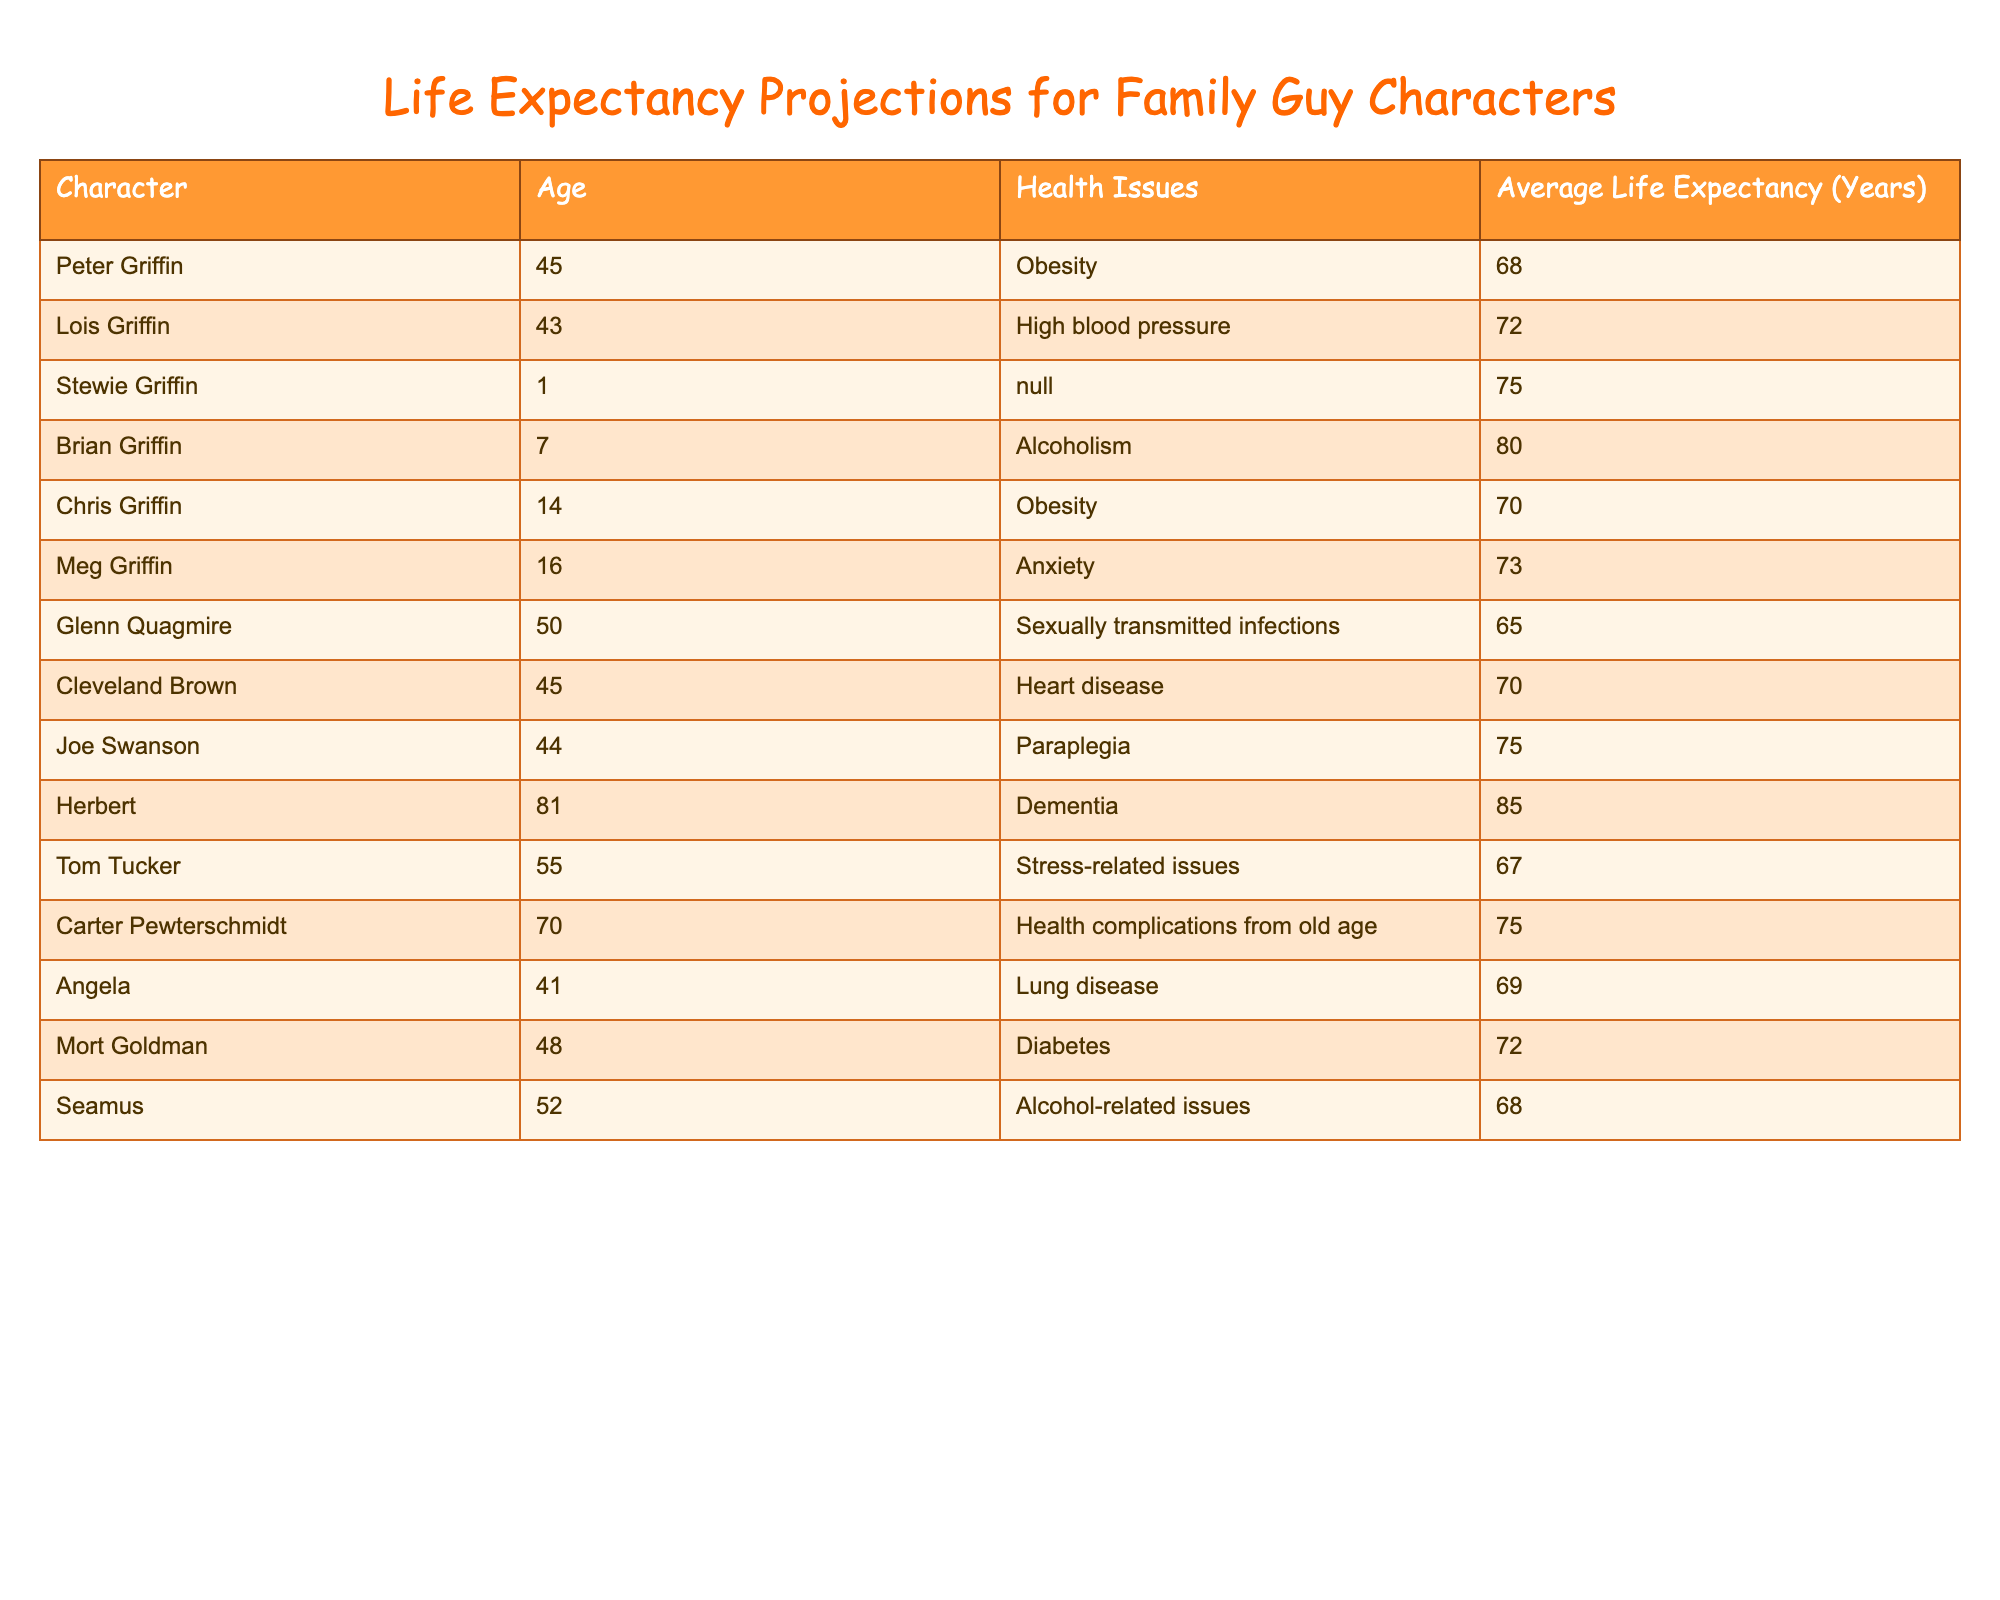What is the average life expectancy for the characters from Family Guy? To find the average life expectancy, we first sum all the life expectancies: (68 + 72 + 75 + 80 + 70 + 73 + 65 + 70 + 75 + 85 + 67 + 75 + 69 + 72 + 68) = 1075. Then we divide that by the total number of characters, which is 15. Therefore, the average life expectancy is 1075 / 15 = 71.67 years.
Answer: 71.67 Which character has the highest life expectancy? By reviewing the life expectancies of all characters, we see that Herbert has the highest score of 85 years.
Answer: Herbert Is it true that Cleveland Brown has a higher life expectancy than Joe Swanson? Cleveland Brown has a life expectancy of 70 years, while Joe Swanson has a life expectancy of 75 years. Since 70 is not greater than 75, the statement is false.
Answer: No What is the difference in life expectancy between Peter Griffin and Glenn Quagmire? Peter Griffin has a life expectancy of 68 years, while Glenn Quagmire has a life expectancy of 65 years. The difference is 68 - 65 = 3 years.
Answer: 3 years How many characters have a life expectancy above 75 years? The characters with life expectancy above 75 years are Stewie Griffin (75), Brian Griffin (80), Joe Swanson (75), Herbert (85), and Carter Pewterschmidt (75). Therefore, there are 5 characters in total.
Answer: 5 characters Is Angela's health issue more serious than that of Chris Griffin? Angela has lung disease, considered serious, while Chris has obesity, also serious but generally seen as less immediately life-threatening than lung disease. However, health issues are subjective. So, this can be seen as true or false based on perspective.
Answer: Yes What is the average life expectancy of characters with obesity as a health issue? The characters with obesity are Peter Griffin (68) and Chris Griffin (70). We sum their life expectancies: 68 + 70 = 138. Then we divide by 2 (the number of characters) to get an average of 138 / 2 = 69 years.
Answer: 69 years Which character is the youngest, and what is their life expectancy? Stewie Griffin is the youngest character at 1 year old, with a life expectancy of 75 years.
Answer: Stewie Griffin, 75 years Is Lois Griffin at a higher risk of shorter life expectancy when compared to Angela? Lois Griffin has a life expectancy of 72 years, while Angela has a life expectancy of 69 years. Since 72 is greater than 69, Lois Griffin is not at higher risk of shorter life expectancy.
Answer: No 